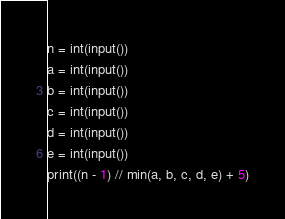<code> <loc_0><loc_0><loc_500><loc_500><_Python_>n = int(input())
a = int(input())
b = int(input())
c = int(input())
d = int(input())
e = int(input())
print((n - 1) // min(a, b, c, d, e) + 5)
</code> 